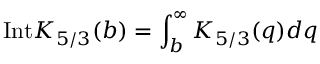<formula> <loc_0><loc_0><loc_500><loc_500>I n t K _ { 5 / 3 } ( b ) = \int _ { b } ^ { \infty } K _ { 5 / 3 } ( q ) d q</formula> 